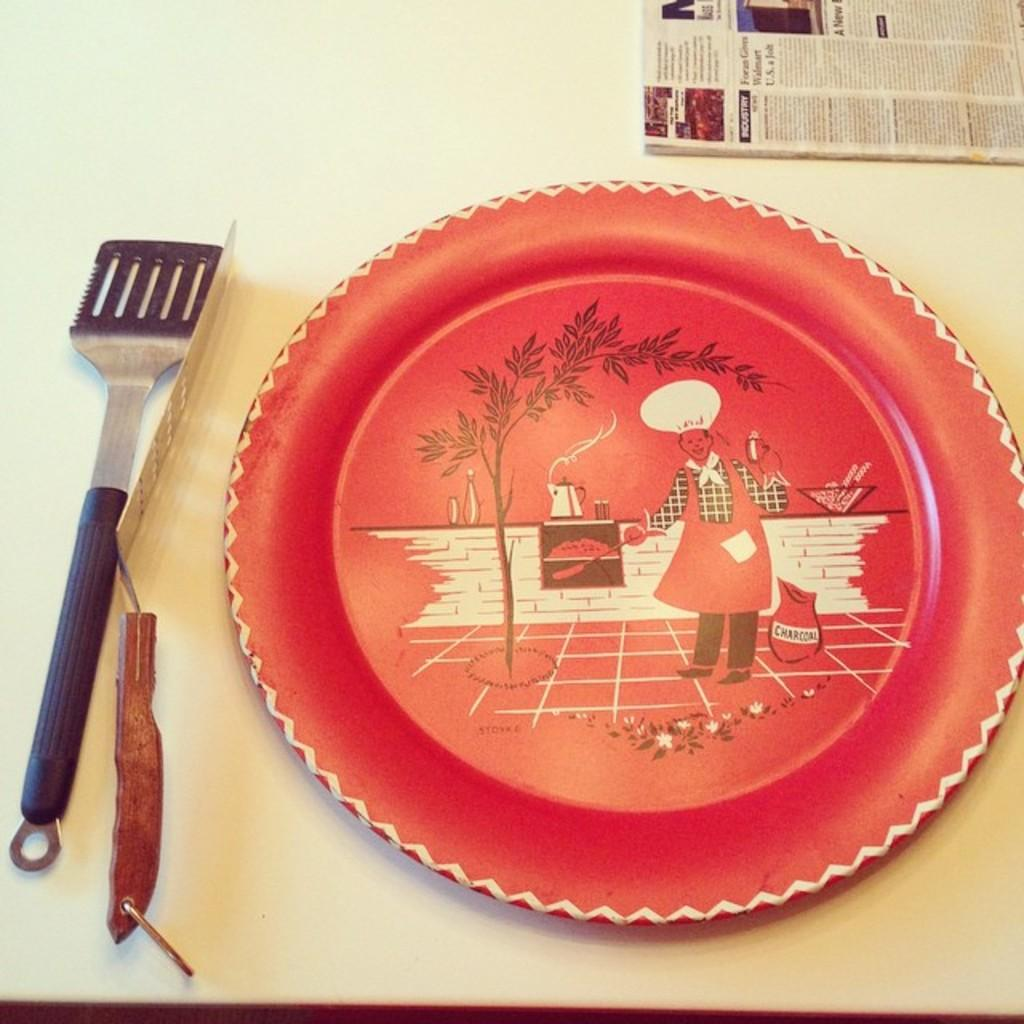What is on the table in the image? There is a plate, a knife, a spoon, and a paper on the table. What utensils are present on the table? There is a knife and a spoon on the table. What else can be found on the table besides utensils? There is a paper on the table. What type of kite is being flown by the person in the image? There is no person or kite present in the image; it only shows a plate, a knife, a spoon, and a paper on the table. 